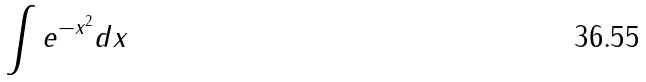<formula> <loc_0><loc_0><loc_500><loc_500>\int e ^ { - x ^ { 2 } } d x</formula> 